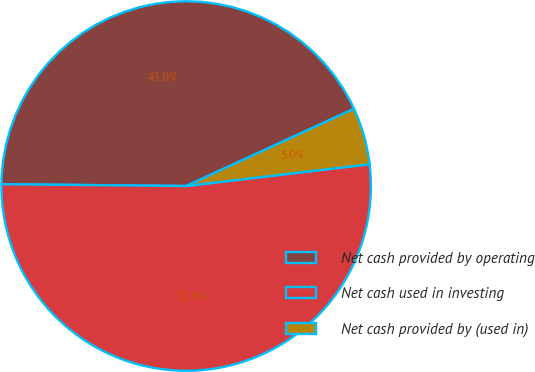<chart> <loc_0><loc_0><loc_500><loc_500><pie_chart><fcel>Net cash provided by operating<fcel>Net cash used in investing<fcel>Net cash provided by (used in)<nl><fcel>42.98%<fcel>52.04%<fcel>4.98%<nl></chart> 